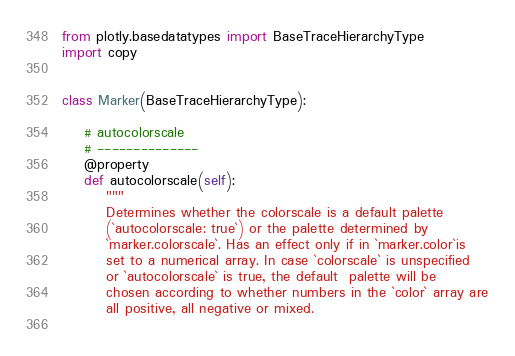<code> <loc_0><loc_0><loc_500><loc_500><_Python_>from plotly.basedatatypes import BaseTraceHierarchyType
import copy


class Marker(BaseTraceHierarchyType):

    # autocolorscale
    # --------------
    @property
    def autocolorscale(self):
        """
        Determines whether the colorscale is a default palette
        (`autocolorscale: true`) or the palette determined by
        `marker.colorscale`. Has an effect only if in `marker.color`is
        set to a numerical array. In case `colorscale` is unspecified
        or `autocolorscale` is true, the default  palette will be
        chosen according to whether numbers in the `color` array are
        all positive, all negative or mixed.
    </code> 